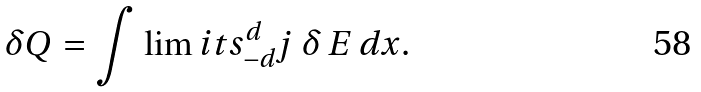Convert formula to latex. <formula><loc_0><loc_0><loc_500><loc_500>\delta Q = \int \lim i t s _ { - d } ^ { d } j \, \delta \, E \, d x .</formula> 